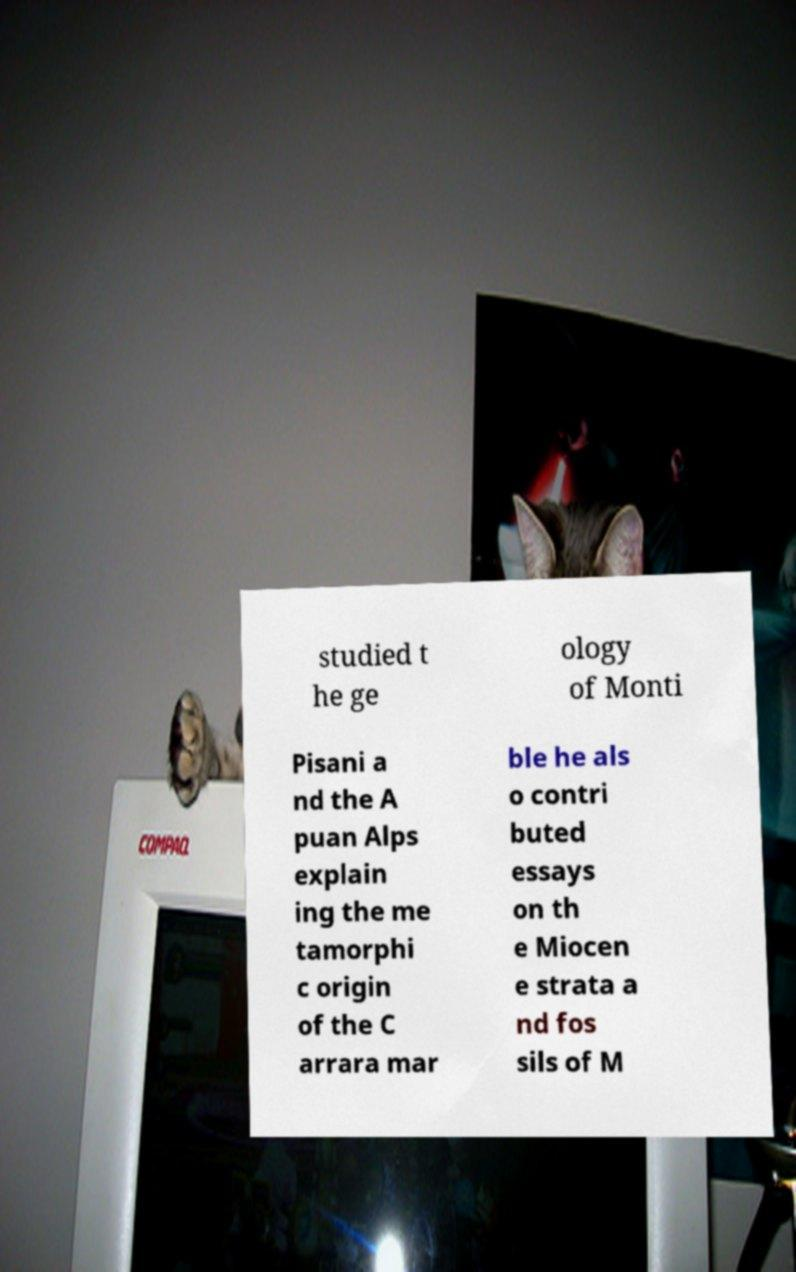Can you accurately transcribe the text from the provided image for me? studied t he ge ology of Monti Pisani a nd the A puan Alps explain ing the me tamorphi c origin of the C arrara mar ble he als o contri buted essays on th e Miocen e strata a nd fos sils of M 